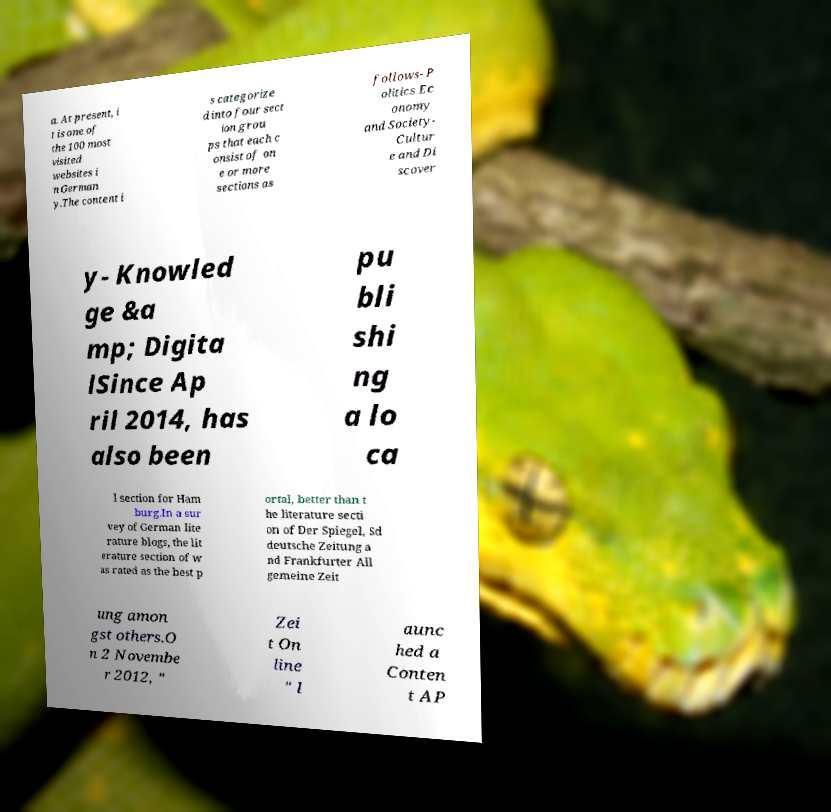Please identify and transcribe the text found in this image. a. At present, i t is one of the 100 most visited websites i n German y.The content i s categorize d into four sect ion grou ps that each c onsist of on e or more sections as follows- P olitics Ec onomy and Society- Cultur e and Di scover y- Knowled ge &a mp; Digita lSince Ap ril 2014, has also been pu bli shi ng a lo ca l section for Ham burg.In a sur vey of German lite rature blogs, the lit erature section of w as rated as the best p ortal, better than t he literature secti on of Der Spiegel, Sd deutsche Zeitung a nd Frankfurter All gemeine Zeit ung amon gst others.O n 2 Novembe r 2012, " Zei t On line " l aunc hed a Conten t AP 